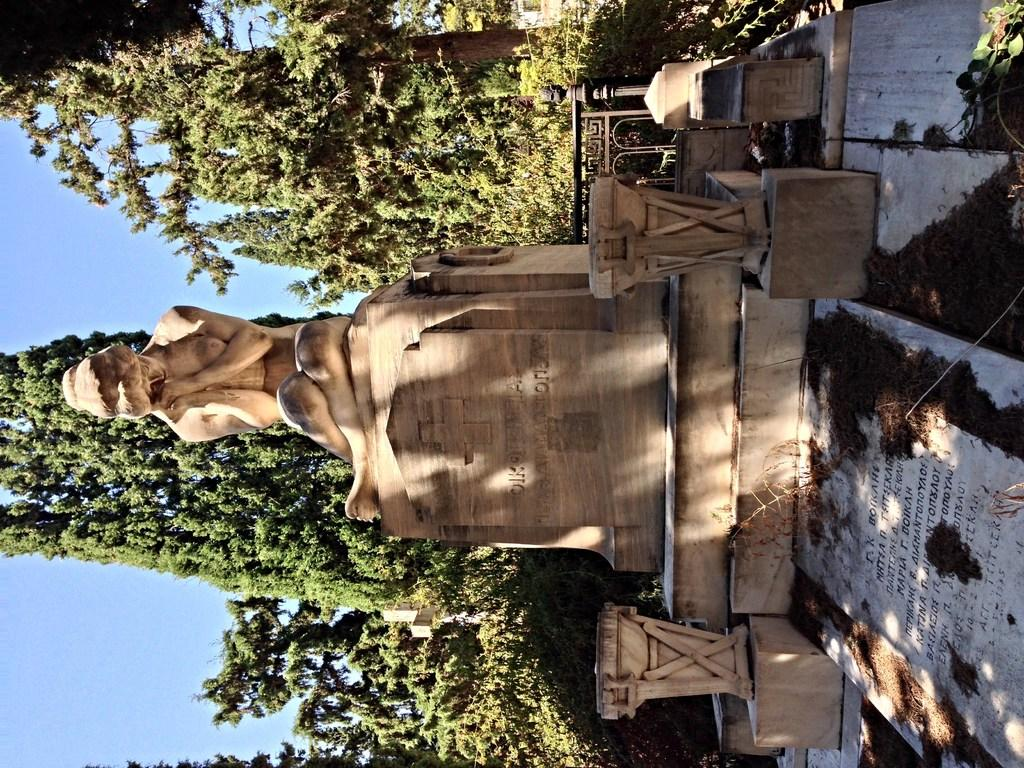What is the main subject of the image? There is a statue of a human in the image. What color is the statue? The statue is in cream color. What type of natural elements can be seen in the image? There are trees in the image. What is visible in the background of the image? The sky is visible in the background of the image. How many chickens are perched on the statue in the image? There are no chickens present in the image; it features a statue of a human. What type of magic is being performed by the statue in the image? There is no magic being performed by the statue in the image; it is a stationary statue. 